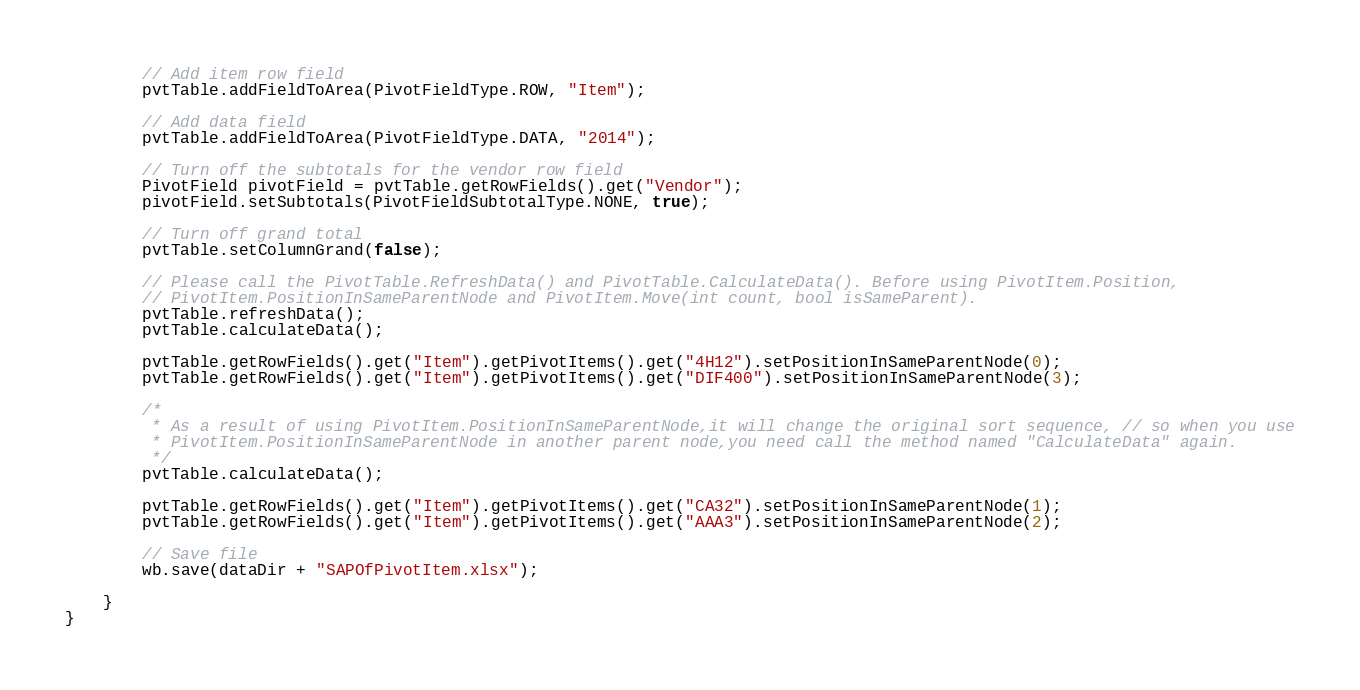Convert code to text. <code><loc_0><loc_0><loc_500><loc_500><_Java_>
		// Add item row field
		pvtTable.addFieldToArea(PivotFieldType.ROW, "Item");

		// Add data field
		pvtTable.addFieldToArea(PivotFieldType.DATA, "2014");

		// Turn off the subtotals for the vendor row field
		PivotField pivotField = pvtTable.getRowFields().get("Vendor");
		pivotField.setSubtotals(PivotFieldSubtotalType.NONE, true);

		// Turn off grand total
		pvtTable.setColumnGrand(false);

		// Please call the PivotTable.RefreshData() and PivotTable.CalculateData(). Before using PivotItem.Position,
		// PivotItem.PositionInSameParentNode and PivotItem.Move(int count, bool isSameParent).
		pvtTable.refreshData();
		pvtTable.calculateData();

		pvtTable.getRowFields().get("Item").getPivotItems().get("4H12").setPositionInSameParentNode(0);
		pvtTable.getRowFields().get("Item").getPivotItems().get("DIF400").setPositionInSameParentNode(3);

		/*
		 * As a result of using PivotItem.PositionInSameParentNode,it will change the original sort sequence, // so when you use
		 * PivotItem.PositionInSameParentNode in another parent node,you need call the method named "CalculateData" again.
		 */
		pvtTable.calculateData();

		pvtTable.getRowFields().get("Item").getPivotItems().get("CA32").setPositionInSameParentNode(1);
		pvtTable.getRowFields().get("Item").getPivotItems().get("AAA3").setPositionInSameParentNode(2);

		// Save file
		wb.save(dataDir + "SAPOfPivotItem.xlsx");

	}
}
</code> 